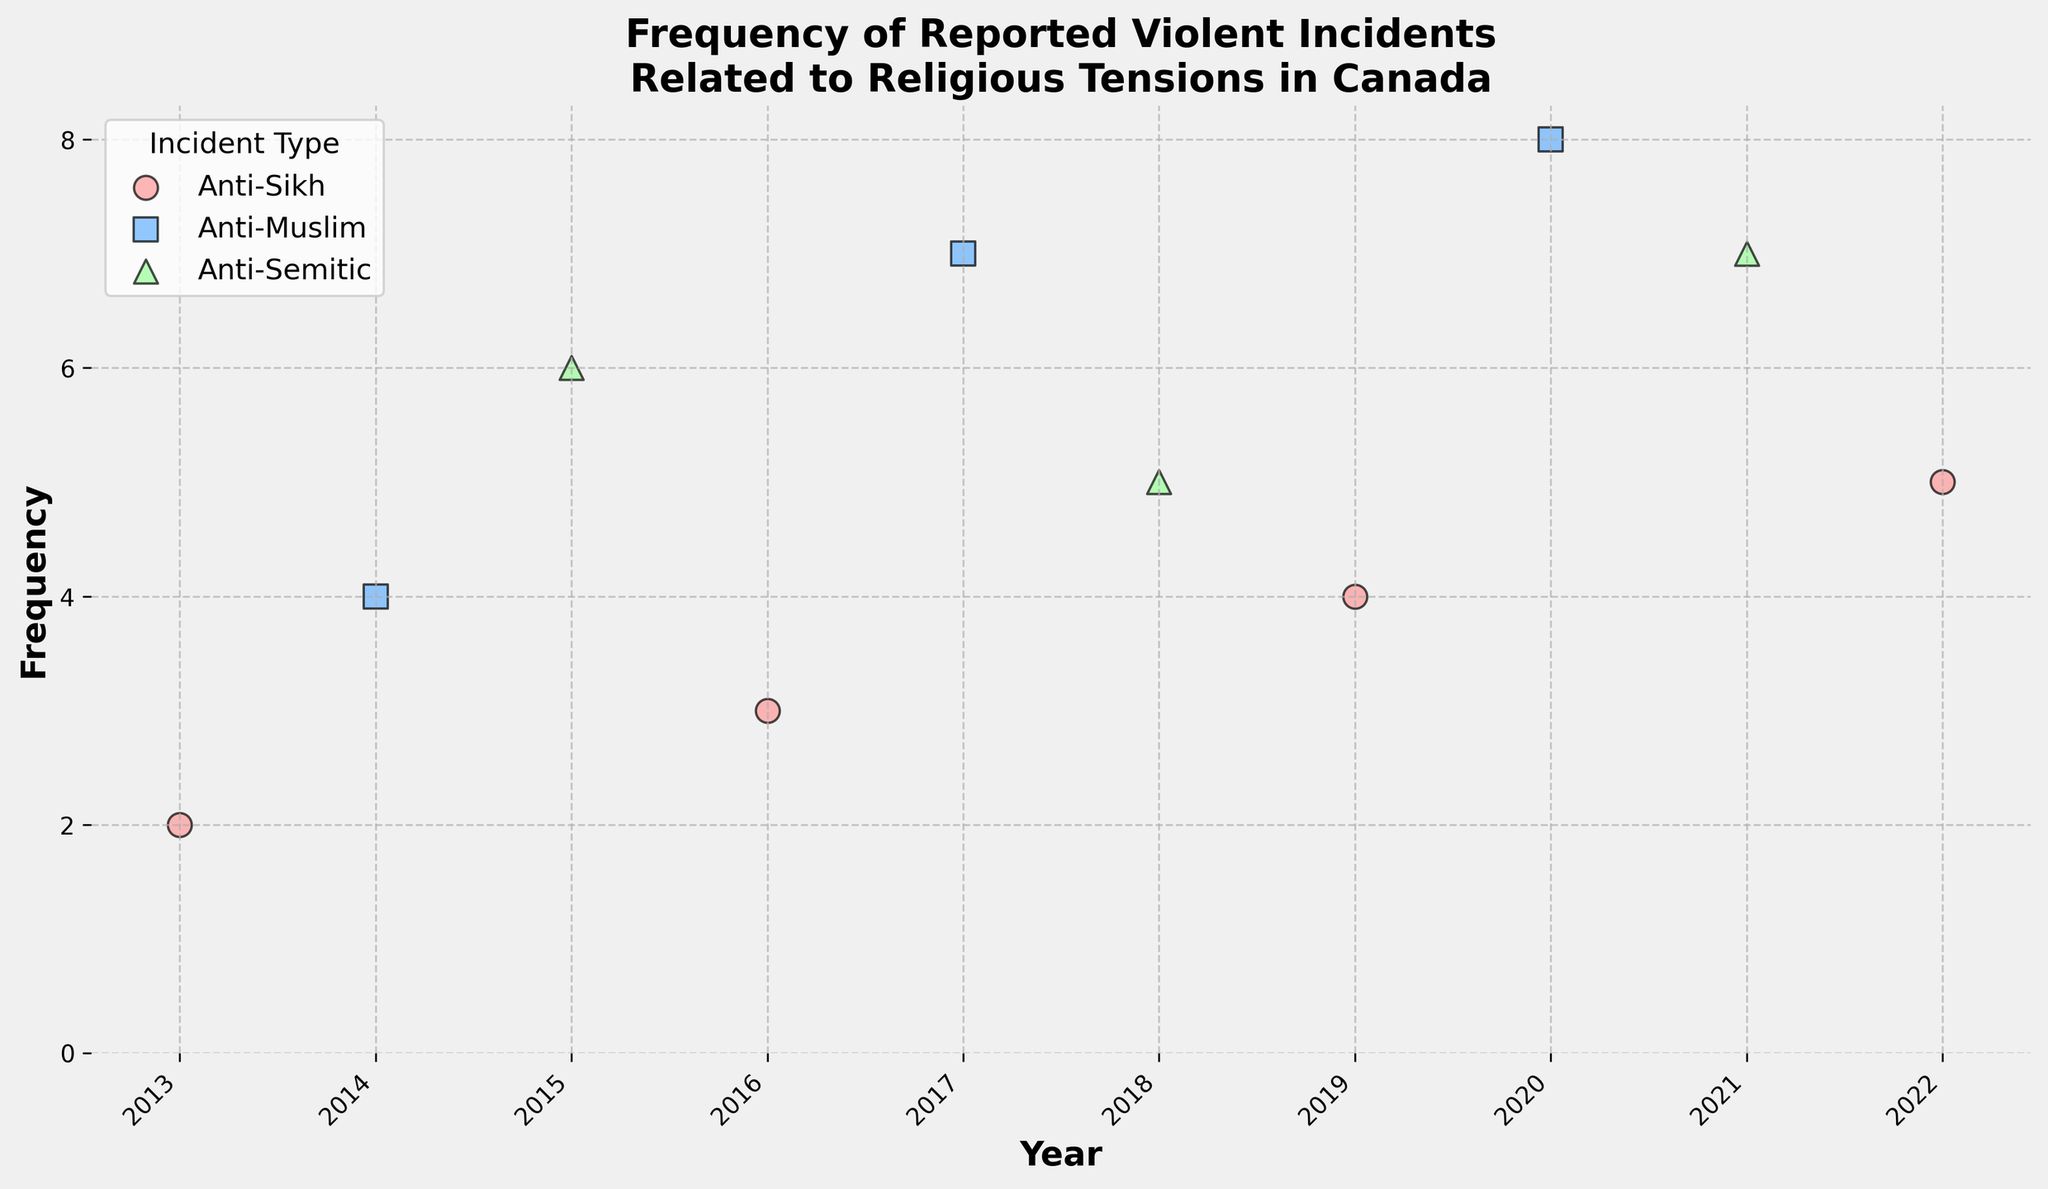What's the title of the plot? The title is written at the top of the plot and reads "Frequency of Reported Violent Incidents Related to Religious Tensions in Canada".
Answer: Frequency of Reported Violent Incidents Related to Religious Tensions in Canada What do the different colors represent in the plot? The legend on the plot shows that different colors represent different incident types: red for Anti-Sikh, blue for Anti-Muslim, and green for Anti-Semitic.
Answer: Different incident types How many Anti-Sikh incidents were reported in 2022? By looking at the data points for the year 2022 and the color red corresponding to Anti-Sikh incidents, we can see that the frequency is 5.
Answer: 5 In which year were the highest number of Anti-Muslim incidents reported? By looking at the blue squares that represent Anti-Muslim incidents, the highest number is 8 in the year 2020.
Answer: 2020 Compare the maximum number of Anti-Semitic incidents reported in any year to the maximum number of Anti-Sikh incidents. Which is higher and by how much? The maximum number of Anti-Semitic incidents is 7 (years 2021), and the maximum number of Anti-Sikh incidents is 5 (year 2022). The difference is calculated as 7 - 5.
Answer: Anti-Semitic by 2 What is the average frequency of all Anti-Muslim incidents reported over the decade? To calculate the average, sum the frequencies of Anti-Muslim incidents (4 + 7 + 8) and divide by the number of data points, which is 3. (4 + 7 + 8) / 3 = 6.33.
Answer: 6.33 Which year had the lowest total number of reported incidents for all incident types combined? Calculate the total incidents for each year: 
2013: 2, 2014: 4, 2015: 6, 2016: 3, 2017: 7, 2018: 5, 2019: 4, 2020: 8, 2021: 7, 2022: 5. Year 2013 has the lowest total with 2 incidents.
Answer: 2013 How do the frequencies of Anti-Sikh incidents in 2016 and 2019 compare? The frequency of Anti-Sikh incidents in 2016 is 3, and in 2019 it is 4. The incidents in 2019 are higher by 1.
Answer: 2019 by 1 What is the trend of Anti-Sikh incidents over the decade? By examining the red scatter points, the frequencies of Anti-Sikh incidents show an increasing trend from 2 in 2013 to 5 in 2022.
Answer: Increasing Based on the plot, did any year have incidents reported for all three types? By examining the scatter points year by year, no single year has data points in all three colors (red, blue, green) indicating incidents from all three types.
Answer: No 